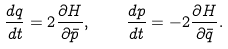<formula> <loc_0><loc_0><loc_500><loc_500>\frac { d q } { d t } = 2 \frac { \partial H } { \partial \bar { p } } , \quad \frac { d p } { d t } = - 2 \frac { \partial H } { \partial \bar { q } } .</formula> 